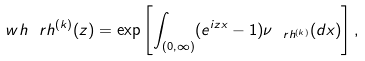Convert formula to latex. <formula><loc_0><loc_0><loc_500><loc_500>\ w h \ r h ^ { ( k ) } ( z ) = \exp \left [ \int _ { ( 0 , \infty ) } ( e ^ { i z x } - 1 ) \nu _ { \ r h ^ { ( k ) } } ( d x ) \right ] ,</formula> 